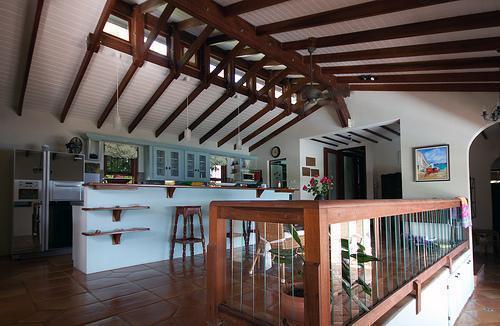How many stools is shown?
Give a very brief answer. 1. 